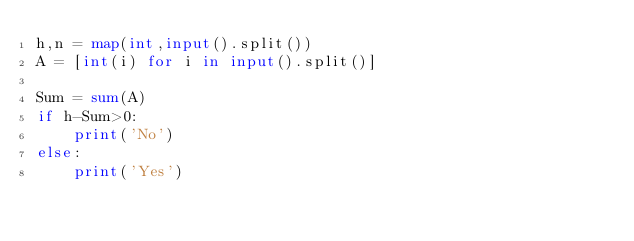Convert code to text. <code><loc_0><loc_0><loc_500><loc_500><_Python_>h,n = map(int,input().split())
A = [int(i) for i in input().split()]

Sum = sum(A)
if h-Sum>0:
    print('No')
else:
    print('Yes')</code> 